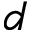Convert formula to latex. <formula><loc_0><loc_0><loc_500><loc_500>d</formula> 